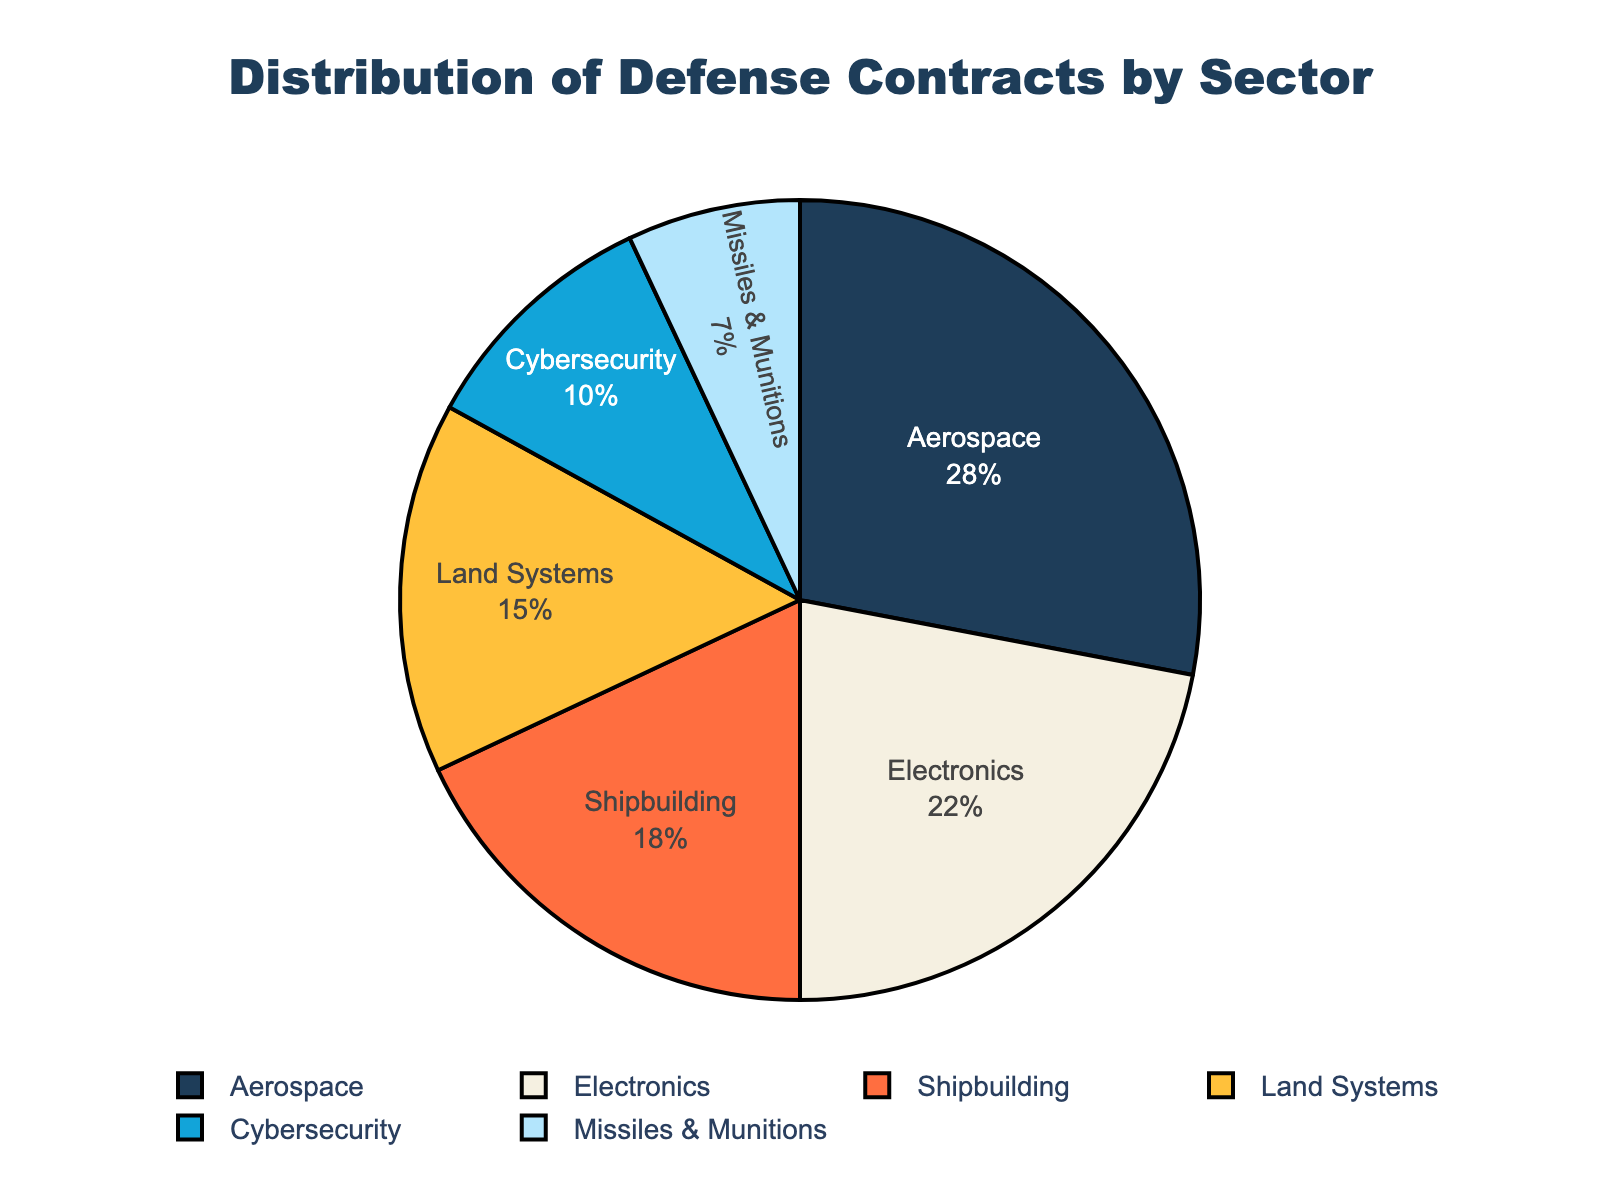what sector holds the smallest percentage of defense contracts? The pie chart represents different sectors by their share of defense contracts. By looking at the chart, the "Missiles & Munitions" sector is the smallest slice.
Answer: Missiles & Munitions which sector has a higher percentage, electronics or land systems? By visually comparing the sizes and percentages inside the slices of the pie chart, the "Electronics" sector has a higher percentage than the "Land Systems" sector. Electronics accounts for 22%, while Land Systems account for 15%.
Answer: Electronics what is the combined percentage of land systems and cybersecurity contracts? To find the combined percentage, we add the percentages of "Land Systems" (15%) and "Cybersecurity" (10%). 15% + 10% = 25%.
Answer: 25% what sector is represented by the airplane emoji? In the pie chart, each sector is represented by an emoji. The text label near the airplane emoji (✈️) is "Aerospace".
Answer: Aerospace how much higher is the percentage of aerospace contracts compared to missiles & munitions? The percentage of "Aerospace" contracts is 28%, and the percentage of "Missiles & Munitions" is 7%. To find how much higher, we calculate 28% - 7% = 21%.
Answer: 21% if we were to distribute the defense contracts equally among all six sectors, what would be the expected percentage for each sector? If the contracts were equally distributed, each sector would receive 1/6 of the total, which translates to (1/6)*100 = 16.67%.
Answer: 16.67% what are the top three sectors in terms of defense contract percentage? The chart shows sectors by percentages, and the top three sectors with the largest slices are "Aerospace" (28%), "Electronics" (22%), and "Shipbuilding" (18%).
Answer: Aerospace, Electronics, Shipbuilding how does the percentage of electronics contracts compare to the combined percentage of both land systems and cybersecurity? The percentage of "Electronics" is 22%. The combined percentage of "Land Systems" (15%) and "Cybersecurity" (10%) is 25%. Since 25% is greater than 22%, the combined percentage of Land Systems and Cybersecurity is higher.
Answer: Lower what percentage of the total is not in the aerospace, electronics, or shipbuilding sectors? Adding the percentages of "Aerospace" (28%), "Electronics" (22%), and "Shipbuilding" (18%) equals 68%. The remaining percentage is 100% - 68% = 32%.
Answer: 32% which sector does the tank emoji represent? The tank emoji is associated with the "Land Systems" sector according to its position and label on the chart.
Answer: Land Systems 